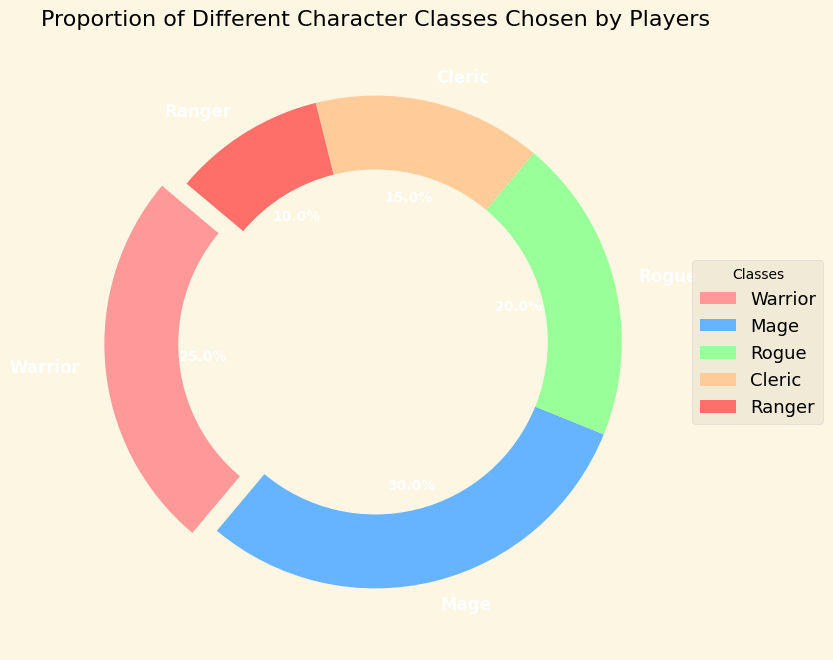What's the most chosen character class? The pie chart shows that the class with the largest proportion is Mage, which accounts for 30% of the classes chosen by players.
Answer: Mage Which class has the smallest proportion of players? The pie chart indicates that the Ranger class has the smallest slice, representing 10% of the players.
Answer: Ranger How many more players choose the Mage than the Ranger class? The proportion of players choosing Mage is 30%, while for Ranger it's 10%. The difference is 30% - 10% = 20%.
Answer: 20% What is the total proportion of players choosing either Rogue or Cleric classes? The chart shows the proportions for Rogue and Cleric are 20% and 15%, respectively. Summing these gives 20% + 15% = 35%.
Answer: 35% Which class has a larger proportion: Warrior or Rogue? By looking at the wedges, Warrior has 25% and Rogue has 20%. Therefore, Warrior has a larger proportion.
Answer: Warrior What class has the second highest proportion of players? According to the chart, the class with the second highest proportion is Warrior, with 25%.
Answer: Warrior If Mage has its proportion reduced by 10%, which class would then have the largest proportion? Reducing Mage's proportion from 30% to 20% would make both Warrior and Mage 20%. Since Warrior would maintain its 25%, it would then have the largest proportion.
Answer: Warrior What's the combined proportion of players choosing Mage, Rogue, and Ranger? The proportions for Mage, Rogue, and Ranger are 30%, 20%, and 10% respectively. The combined proportion is 30% + 20% + 10% = 60%.
Answer: 60% What is the average proportion of all the character classes? Adding the proportions for all classes: 25% (Warrior) + 30% (Mage) + 20% (Rogue) + 15% (Cleric) + 10% (Ranger) gives 100%. The average is 100% / 5 = 20%.
Answer: 20% Which slice is visually emphasized? In the pie chart, the slice representing the Warrior class is exploded outward, making it visually emphasized.
Answer: Warrior 